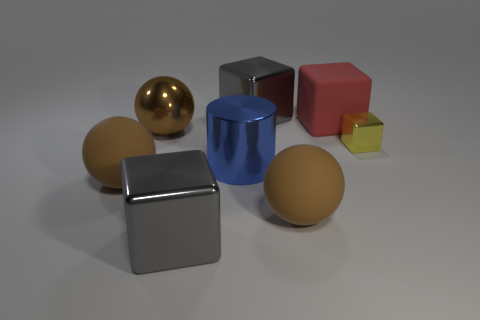The small block has what color? The small block in the image appears to be yellow, catching light in such a way that emphasizes its smooth surface and sharp edges. 